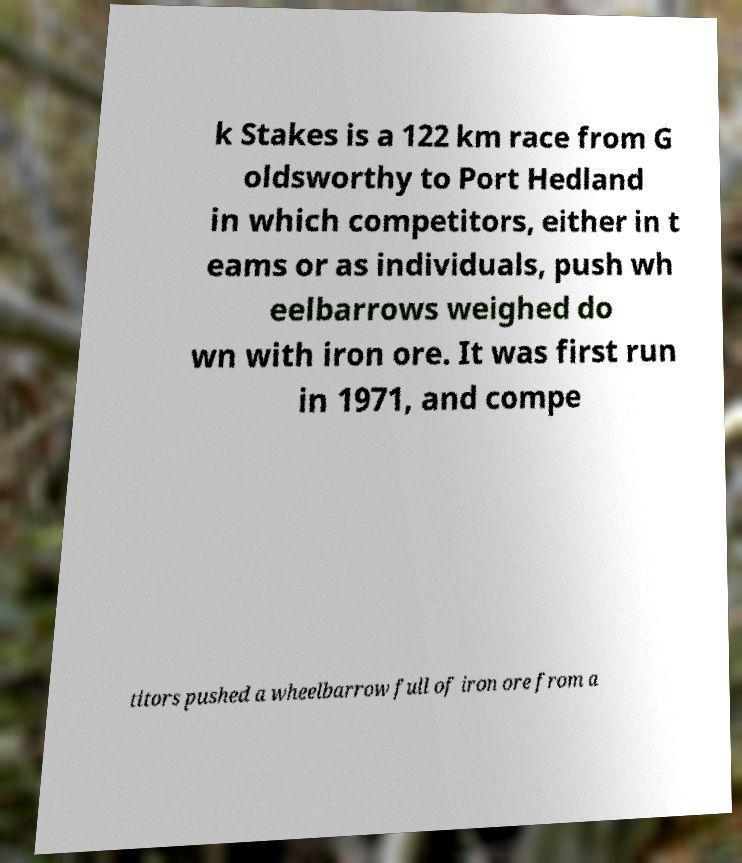For documentation purposes, I need the text within this image transcribed. Could you provide that? k Stakes is a 122 km race from G oldsworthy to Port Hedland in which competitors, either in t eams or as individuals, push wh eelbarrows weighed do wn with iron ore. It was first run in 1971, and compe titors pushed a wheelbarrow full of iron ore from a 